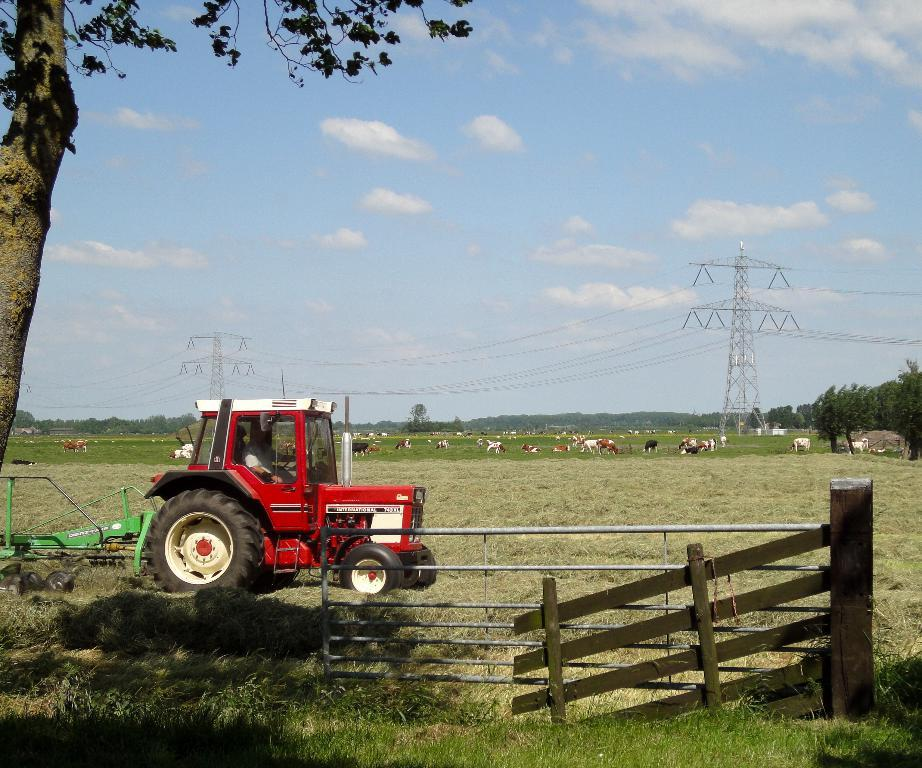What is located on the grass in the image? There is a vehicle on the grass in the image. What type of barrier can be seen in the image? There is a fence in the image. What type of living organisms are present in the image? Animals are present in the image. What type of infrastructure can be seen in the image? Cell towers are visible in the image. What type of man-made structures are present in the image? Cables are present in the image. What type of natural elements are present in the image? Trees are in the image. What is visible in the background of the image? The sky is visible in the background of the image. What type of metal is used to make the songs in the image? There is no mention of songs or metal in the image; it features a vehicle on the grass, a fence, animals, cell towers, cables, trees, and the sky. What type of quiver is visible in the image? There is no quiver present in the image. 